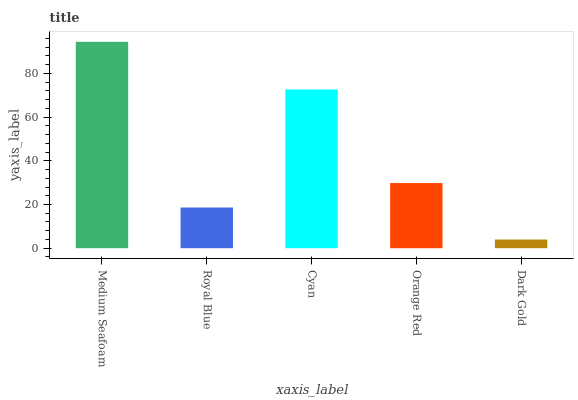Is Dark Gold the minimum?
Answer yes or no. Yes. Is Medium Seafoam the maximum?
Answer yes or no. Yes. Is Royal Blue the minimum?
Answer yes or no. No. Is Royal Blue the maximum?
Answer yes or no. No. Is Medium Seafoam greater than Royal Blue?
Answer yes or no. Yes. Is Royal Blue less than Medium Seafoam?
Answer yes or no. Yes. Is Royal Blue greater than Medium Seafoam?
Answer yes or no. No. Is Medium Seafoam less than Royal Blue?
Answer yes or no. No. Is Orange Red the high median?
Answer yes or no. Yes. Is Orange Red the low median?
Answer yes or no. Yes. Is Medium Seafoam the high median?
Answer yes or no. No. Is Royal Blue the low median?
Answer yes or no. No. 